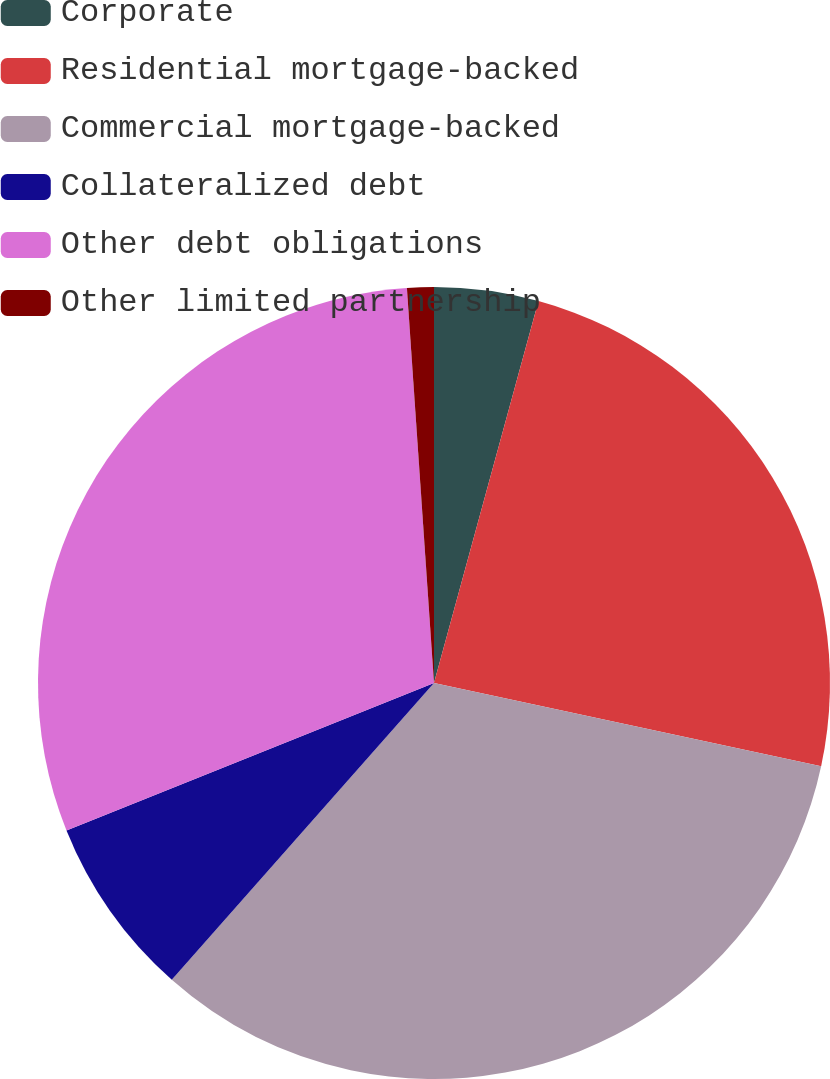<chart> <loc_0><loc_0><loc_500><loc_500><pie_chart><fcel>Corporate<fcel>Residential mortgage-backed<fcel>Commercial mortgage-backed<fcel>Collateralized debt<fcel>Other debt obligations<fcel>Other limited partnership<nl><fcel>4.25%<fcel>24.13%<fcel>33.15%<fcel>7.41%<fcel>29.99%<fcel>1.09%<nl></chart> 